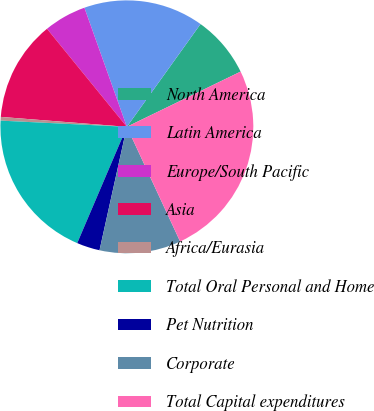Convert chart. <chart><loc_0><loc_0><loc_500><loc_500><pie_chart><fcel>North America<fcel>Latin America<fcel>Europe/South Pacific<fcel>Asia<fcel>Africa/Eurasia<fcel>Total Oral Personal and Home<fcel>Pet Nutrition<fcel>Corporate<fcel>Total Capital expenditures<nl><fcel>7.91%<fcel>15.35%<fcel>5.43%<fcel>12.87%<fcel>0.47%<fcel>19.36%<fcel>2.95%<fcel>10.39%<fcel>25.27%<nl></chart> 